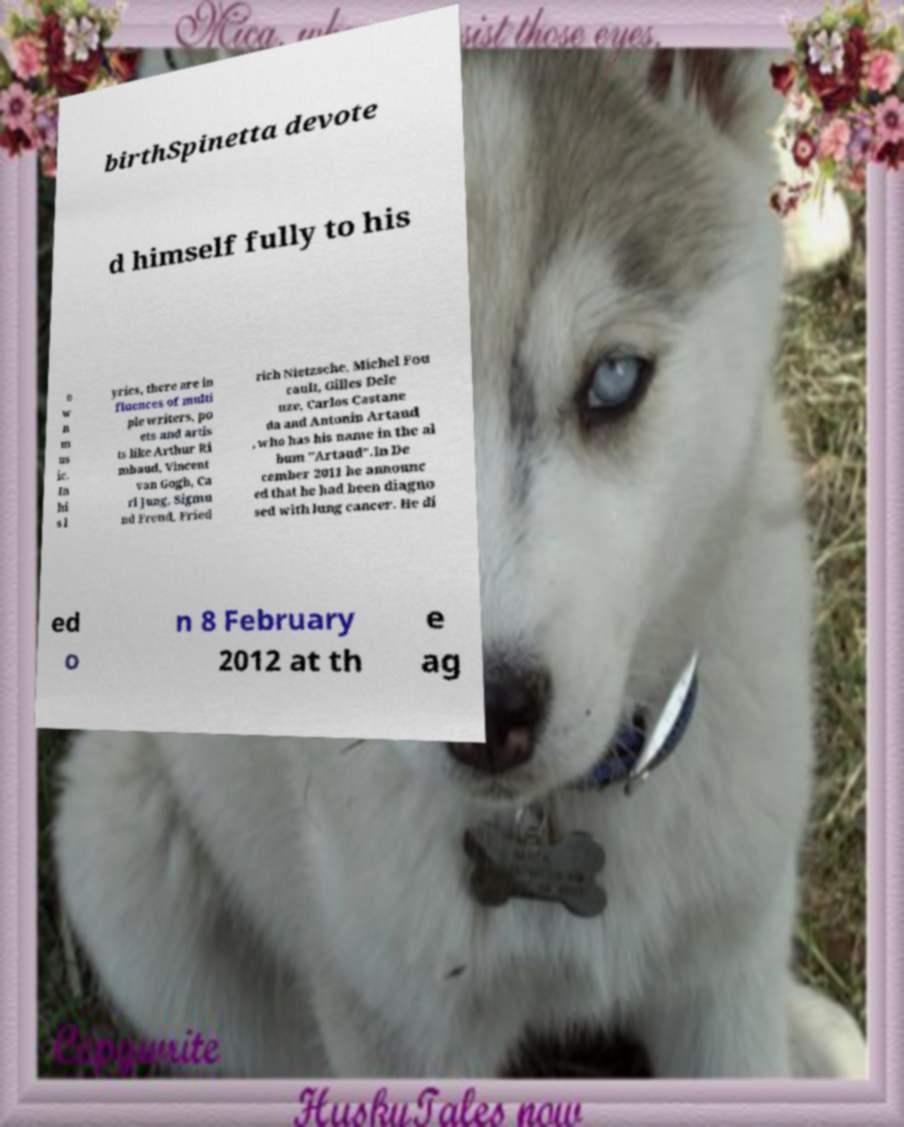Can you accurately transcribe the text from the provided image for me? birthSpinetta devote d himself fully to his o w n m us ic. In hi s l yrics, there are in fluences of multi ple writers, po ets and artis ts like Arthur Ri mbaud, Vincent van Gogh, Ca rl Jung, Sigmu nd Freud, Fried rich Nietzsche, Michel Fou cault, Gilles Dele uze, Carlos Castane da and Antonin Artaud , who has his name in the al bum "Artaud".In De cember 2011 he announc ed that he had been diagno sed with lung cancer. He di ed o n 8 February 2012 at th e ag 